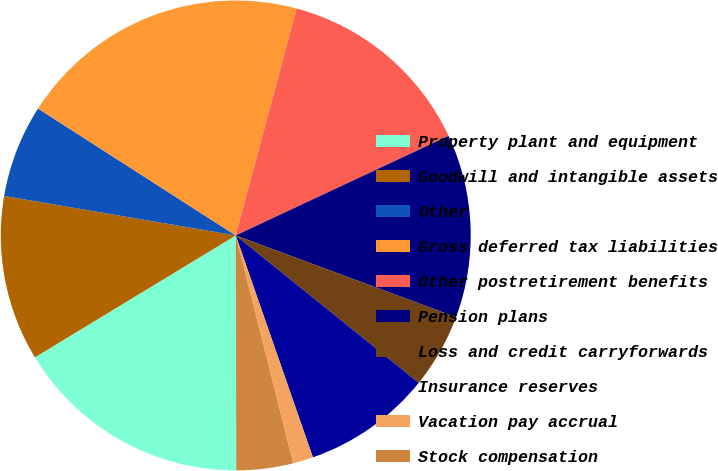Convert chart. <chart><loc_0><loc_0><loc_500><loc_500><pie_chart><fcel>Property plant and equipment<fcel>Goodwill and intangible assets<fcel>Other<fcel>Gross deferred tax liabilities<fcel>Other postretirement benefits<fcel>Pension plans<fcel>Loss and credit carryforwards<fcel>Insurance reserves<fcel>Vacation pay accrual<fcel>Stock compensation<nl><fcel>16.35%<fcel>11.37%<fcel>6.39%<fcel>20.09%<fcel>13.86%<fcel>12.62%<fcel>5.14%<fcel>8.88%<fcel>1.4%<fcel>3.89%<nl></chart> 